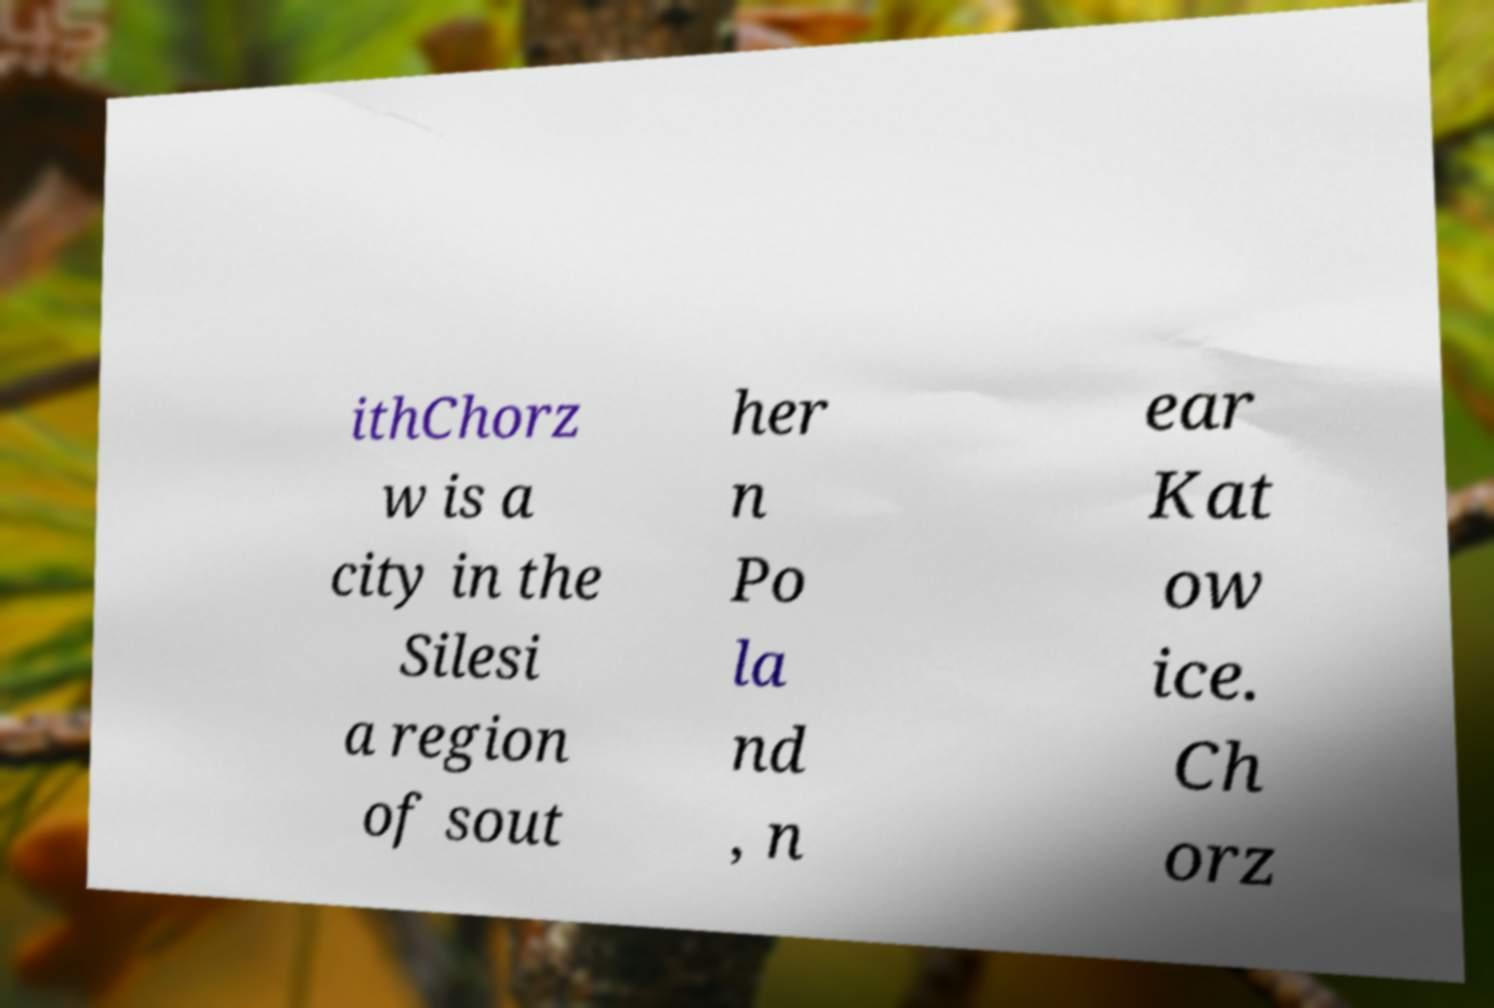Could you assist in decoding the text presented in this image and type it out clearly? ithChorz w is a city in the Silesi a region of sout her n Po la nd , n ear Kat ow ice. Ch orz 